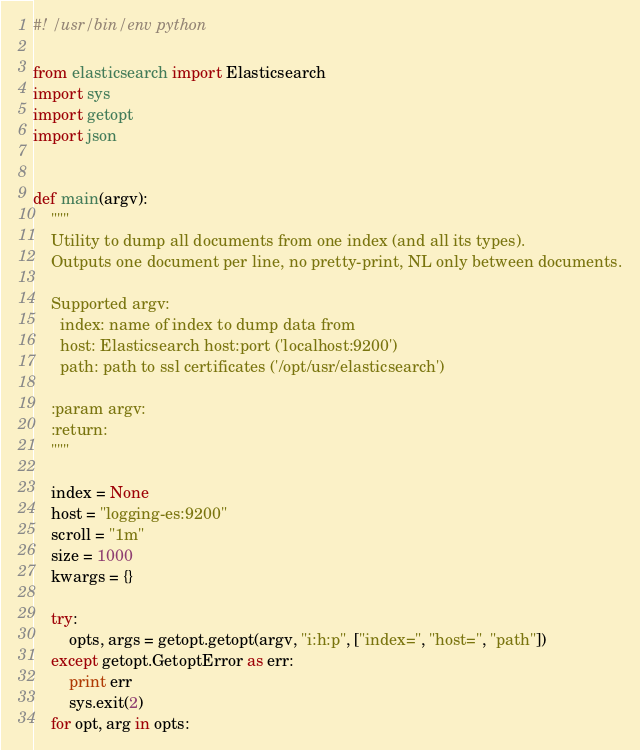Convert code to text. <code><loc_0><loc_0><loc_500><loc_500><_Python_>#! /usr/bin/env python

from elasticsearch import Elasticsearch
import sys
import getopt
import json


def main(argv):
    """
    Utility to dump all documents from one index (and all its types).
    Outputs one document per line, no pretty-print, NL only between documents.

    Supported argv:
      index: name of index to dump data from
      host: Elasticsearch host:port ('localhost:9200')
      path: path to ssl certificates ('/opt/usr/elasticsearch')

    :param argv:
    :return:
    """

    index = None
    host = "logging-es:9200"
    scroll = "1m"
    size = 1000
    kwargs = {}

    try:
        opts, args = getopt.getopt(argv, "i:h:p", ["index=", "host=", "path"])
    except getopt.GetoptError as err:
        print err
        sys.exit(2)
    for opt, arg in opts:</code> 